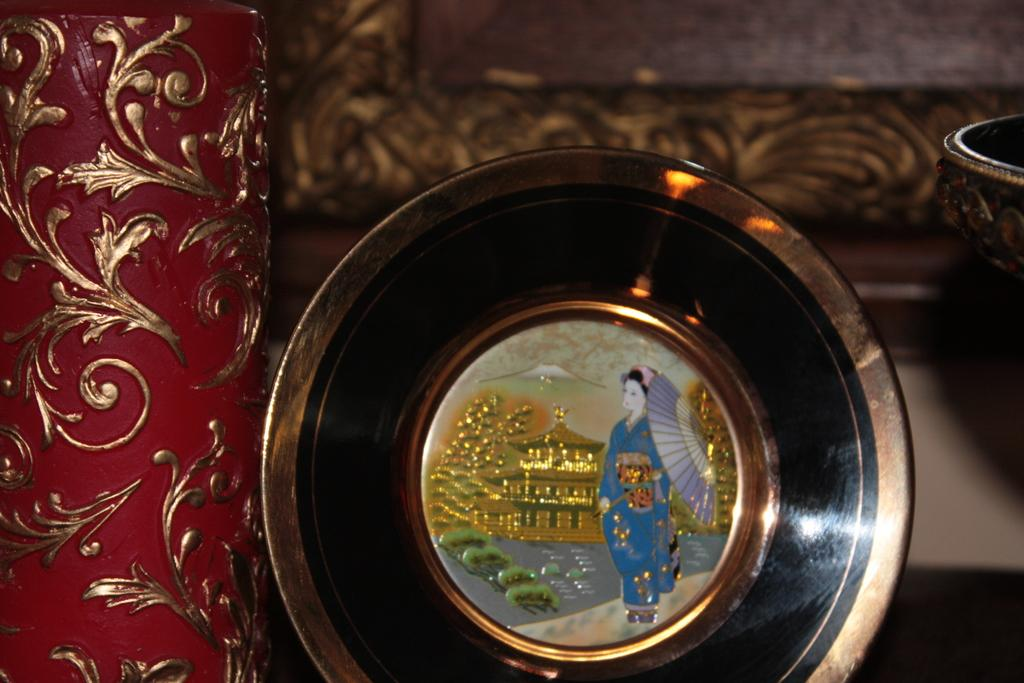What type of material is the object in the image made of? The object in the image is made up of metal. What can be seen in the background of the image? There is a frame in the background of the image. What is the color and location of the other object in the image? The other object is in red color and is located on the left side of the image. How many rabbits are sitting on the throne in the image? There is no throne or rabbits present in the image. What type of team is visible in the image? There is no team visible in the image. 